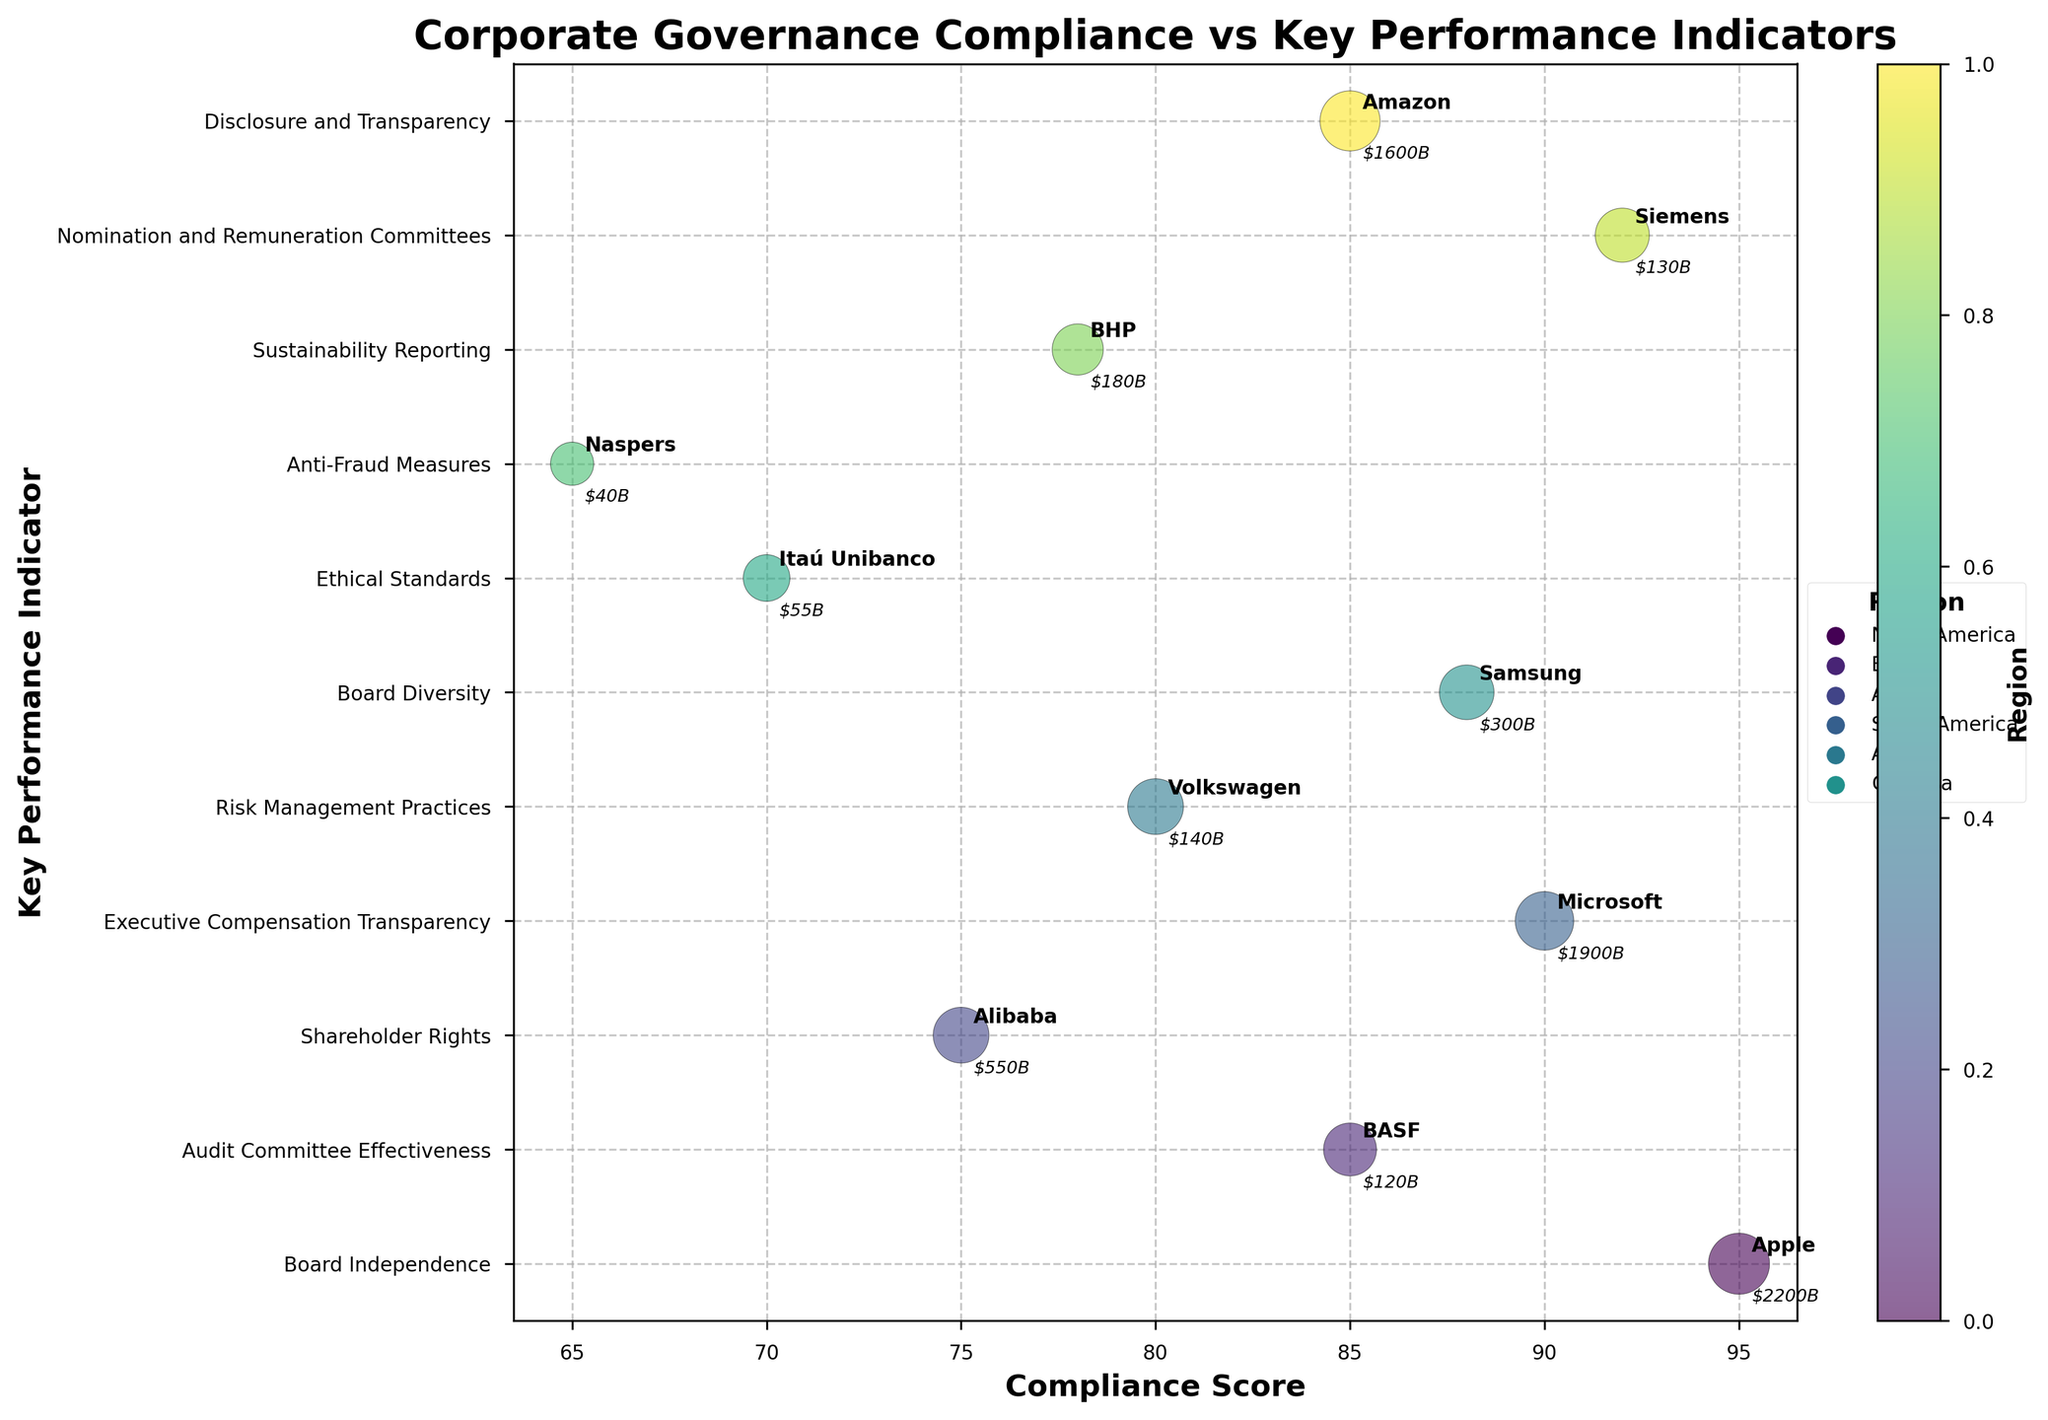What is the title of the figure? The title of the figure is displayed at the top and is labeled "Corporate Governance Compliance vs Key Performance Indicators".
Answer: Corporate Governance Compliance vs Key Performance Indicators Which region has the highest compliance score? By observing the bubble chart, look for the bubble with the highest value on the x-axis labeled "Compliance Score". North America (Apple) has the highest compliance score of 95.
Answer: North America What is the company valuation of BASF in Europe? Identify BASF in Europe on the bubble chart and refer to the annotated company valuation. BASF is annotated with "$120B".
Answer: $120B Which company has the largest bubble size in North America? Look for bubbles in North America and identify the largest one by size. Apple has the largest bubble size in North America with a size of 60.
Answer: Apple How many companies from the figure are located in Asia? Count the number of bubbles belonging to the region "Asia". There are 2 companies: Alibaba and Samsung.
Answer: 2 Which company from South America has a compliance score of 70? Locate the bubble corresponding to South America with a compliance score of 70. The company is Itaú Unibanco.
Answer: Itaú Unibanco What is the key performance indicator associated with Naspers from Africa? Find Naspers in Africa on the chart and note its Key Performance Indicator. Naspers is associated with "Anti-Fraud Measures".
Answer: Anti-Fraud Measures Compare the company valuations of Apple and Amazon in North America. Which one is higher? Identify the company valuations of Apple and Amazon; Apple is $2200B and Amazon is $1600B. Compare both values to see that Apple's valuation is higher.
Answer: Apple What is the average compliance score of companies in Europe? Identify the compliance scores of companies in Europe (85, 80, 92), sum them (85 + 80 + 92 = 257), and divide by the number of companies (257 / 3 ≈ 85.67).
Answer: 85.67 Which company in North America has the lowest compliance score? Compare the compliance scores of companies in North America: Apple (95), Microsoft (90), Amazon (85). Amazon has the lowest compliance score of 85.
Answer: Amazon 